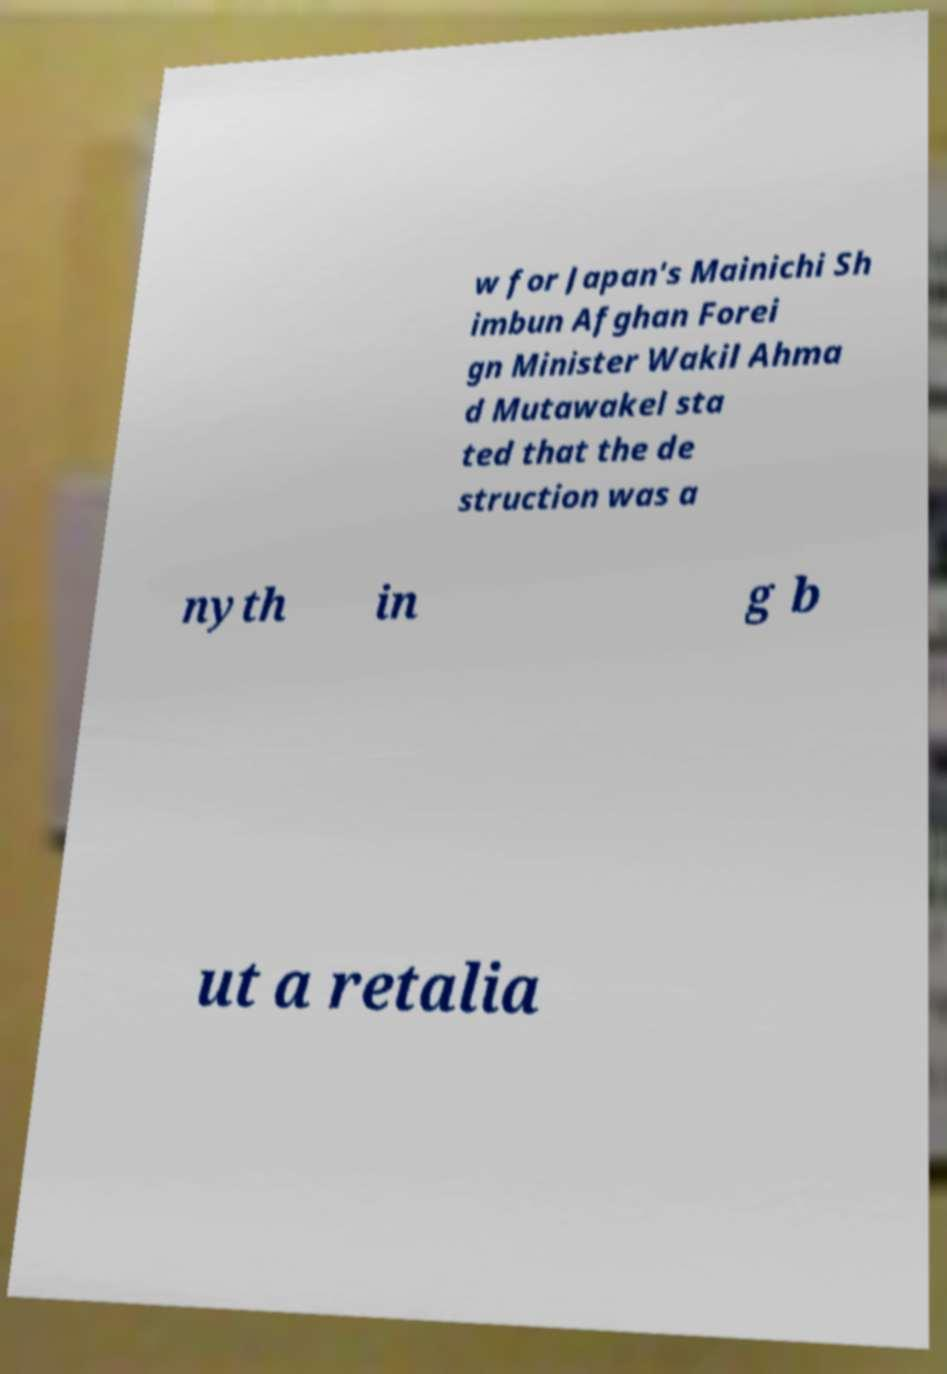Could you extract and type out the text from this image? w for Japan's Mainichi Sh imbun Afghan Forei gn Minister Wakil Ahma d Mutawakel sta ted that the de struction was a nyth in g b ut a retalia 